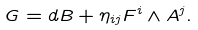Convert formula to latex. <formula><loc_0><loc_0><loc_500><loc_500>G = d B + \eta _ { i j } F ^ { i } \wedge A ^ { j } .</formula> 